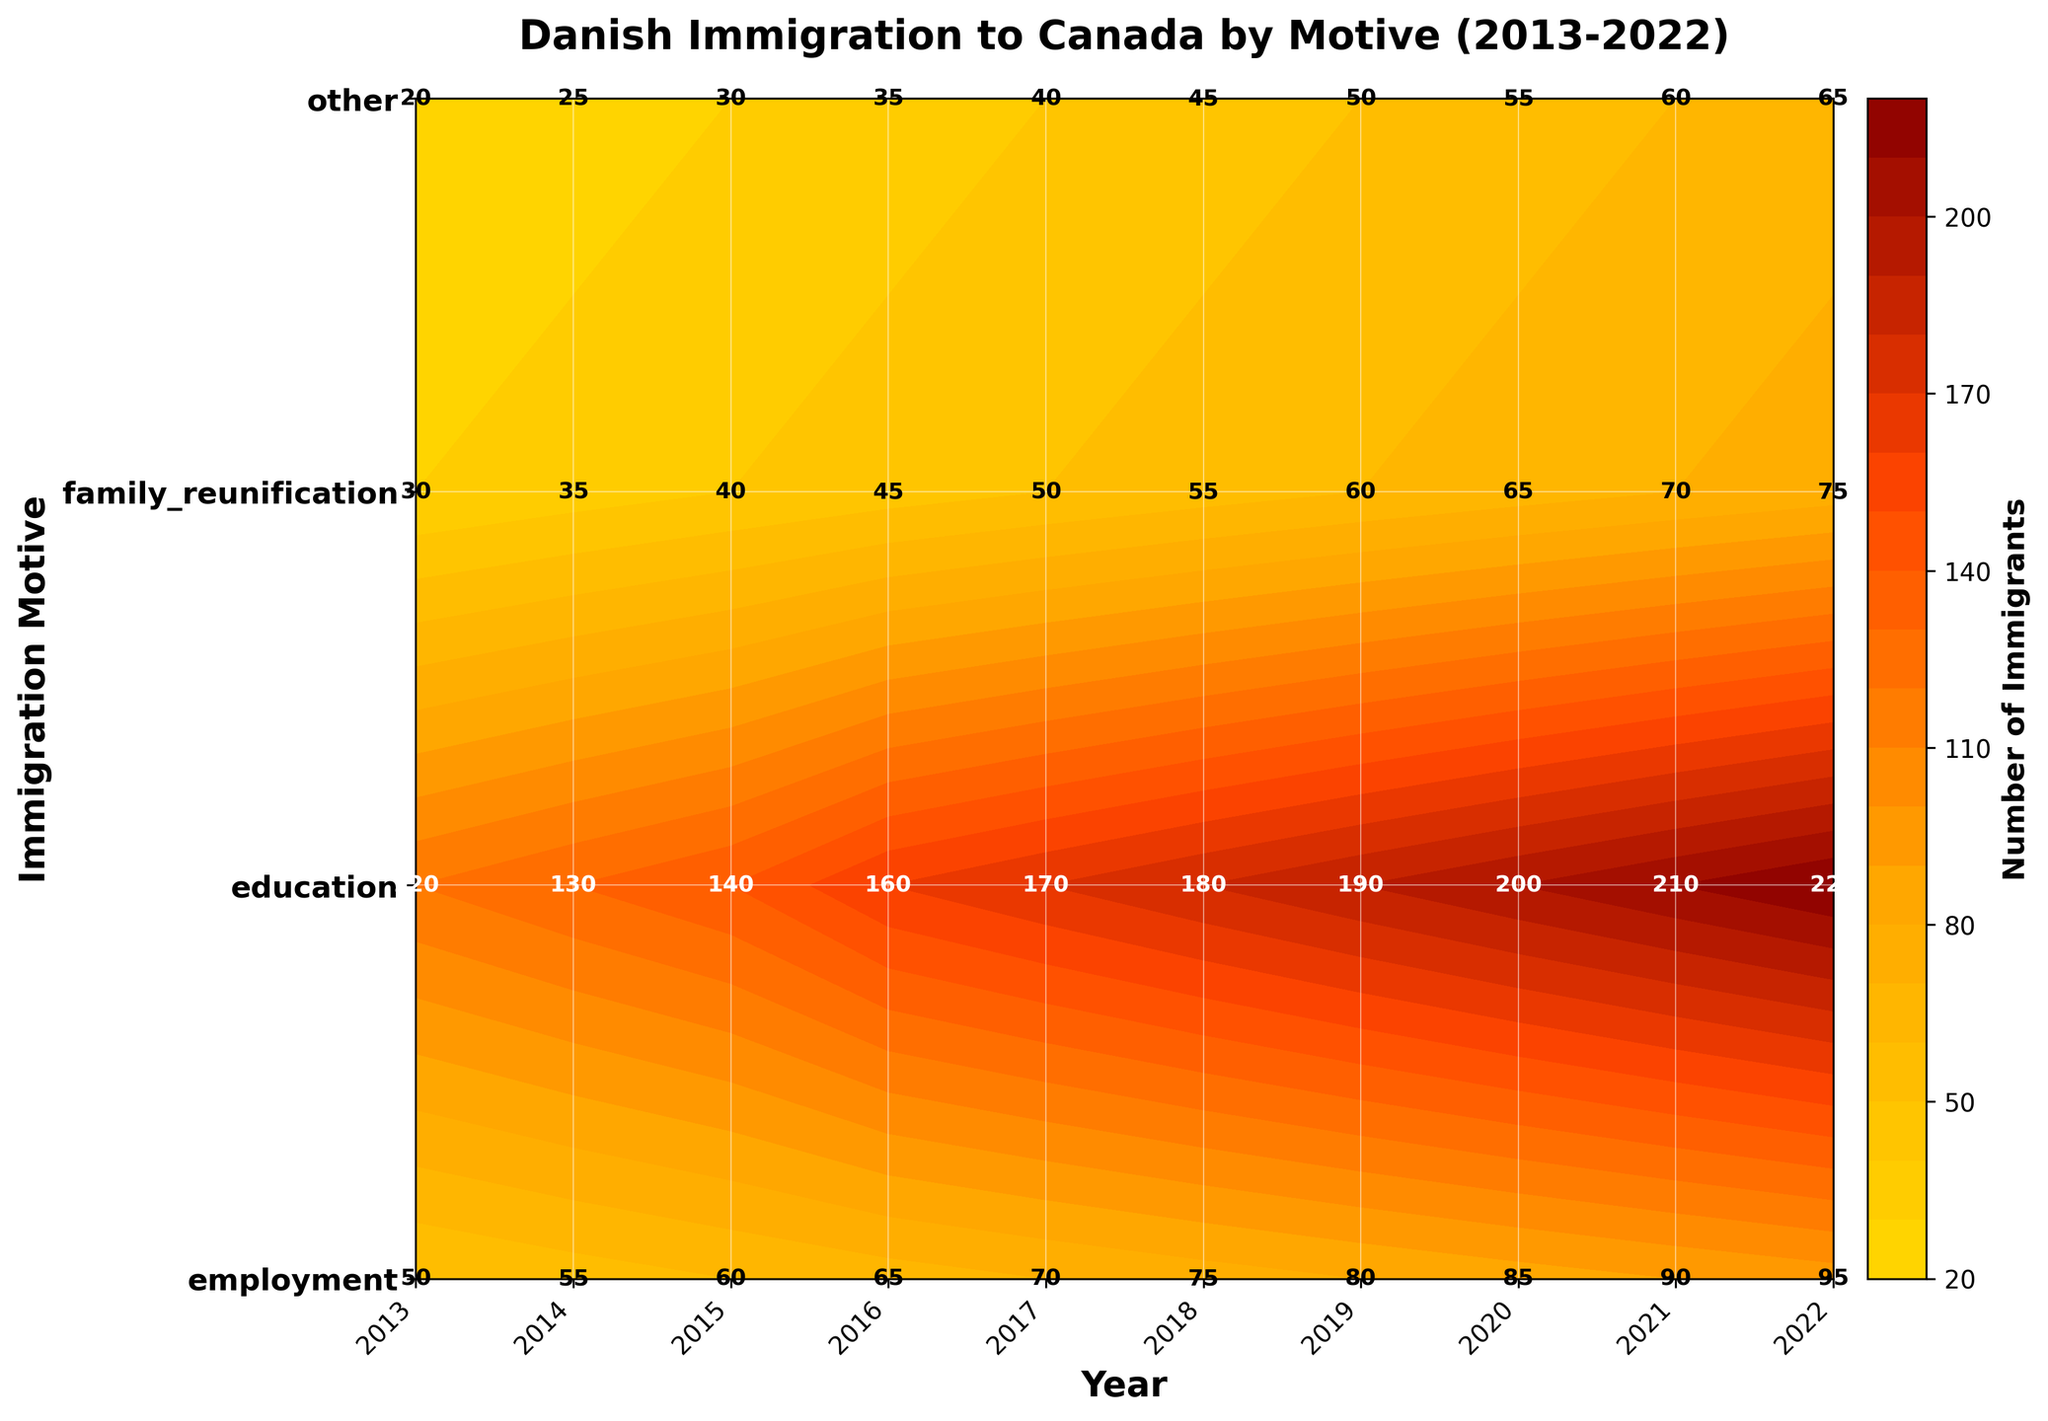what is the title of the figure? The title is usually located at the top of the figure. It helps to understand the main focus of the plot. Check the larger, bold text at the top of the image.
Answer: Danish Immigration to Canada by Motive (2013-2022) What year had the highest number of family reunification immigrants? To determine this, look at the 'family reunification' row and identify the year with the highest number stated in the labels.
Answer: 2022 How many total employment immigrants were there between 2013 and 2016? Add up the number of employment immigrants for the years 2013, 2014, 2015, and 2016: 120 + 130 + 140 + 160 = 550
Answer: 550 Which category had the least number of immigrants in 2013? Compare the numbers for each category in the year 2013 and identify the smallest one: employment (120), education (50), family reunification (30), other (20)
Answer: other Compare the number of education immigrants in 2016 and 2022. Which year had more? Check the figure for the number of education immigrants in 2016 and 2022 and compare these numbers: 65 (2016) vs. 95 (2022)
Answer: 2022 What is the general trend of immigration for employment over the given years? Look at the employment numbers from 2013 to 2022. Note if the numbers increase, decrease, or stay the same. The numbers show a consistent increase: 120, 130, 140, 160, 170, 180, 190, 200, 210, 220
Answer: Increase Is there any year where the number of immigrants in the 'other' category matches that in the 'family reunification' category? Compare the numbers for each year in both 'other' and 'family reunification' categories to see if they ever match. No data points match between 'other' and 'family reunification' labels.
Answer: No What is the average number of immigrants in the 'education' category from 2013 to 2017? Add the numbers for the education immigrants from 2013 to 2017 and then divide by 5: (50 + 55 + 60 + 65 + 70) / 5 = 300 / 5 = 60
Answer: 60 Which motive had the highest number of immigrants in 2019? Compare the numbers of immigrants for each motive in the year 2019 and identify the highest number: employment (190), education (80), family reunification (60), other (50)
Answer: employment 